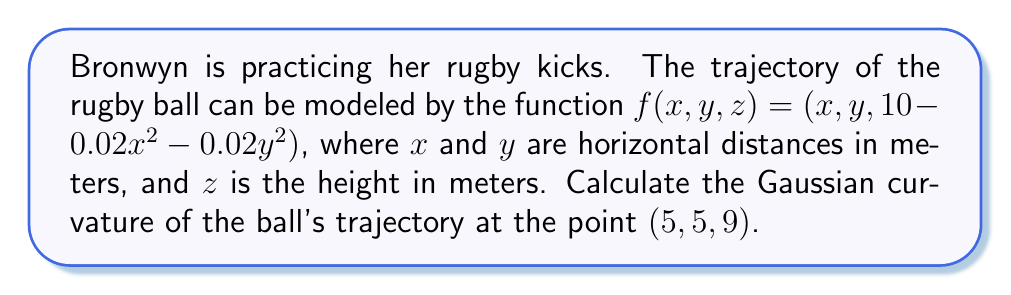What is the answer to this math problem? To find the Gaussian curvature, we need to follow these steps:

1) First, we need to calculate the first and second partial derivatives of $f$:

   $f_x = (1, 0, -0.04x)$
   $f_y = (0, 1, -0.04y)$
   $f_{xx} = (0, 0, -0.04)$
   $f_{yy} = (0, 0, -0.04)$
   $f_{xy} = f_{yx} = (0, 0, 0)$

2) Next, we need to calculate the coefficients of the first fundamental form:

   $E = f_x \cdot f_x = 1 + 0.0016x^2$
   $F = f_x \cdot f_y = 0.0016xy$
   $G = f_y \cdot f_y = 1 + 0.0016y^2$

3) Now, we calculate the unit normal vector:

   $\vec{N} = \frac{f_x \times f_y}{|f_x \times f_y|} = \frac{(0.04x, 0.04y, 1)}{\sqrt{1 + 0.0016x^2 + 0.0016y^2}}$

4) We can now calculate the coefficients of the second fundamental form:

   $L = \vec{N} \cdot f_{xx} = \frac{-0.04}{\sqrt{1 + 0.0016x^2 + 0.0016y^2}}$
   $M = \vec{N} \cdot f_{xy} = 0$
   $N = \vec{N} \cdot f_{yy} = \frac{-0.04}{\sqrt{1 + 0.0016x^2 + 0.0016y^2}}$

5) The Gaussian curvature is given by:

   $K = \frac{LN - M^2}{EG - F^2}$

6) Substituting the values at the point (5, 5, 9):

   $K = \frac{(-0.04)(-0.04) - 0^2}{(1.04)(1.04) - (0.04)^2} = \frac{0.0016}{1.0784} \approx 0.001484$
Answer: $K \approx 0.001484$ $m^{-2}$ 